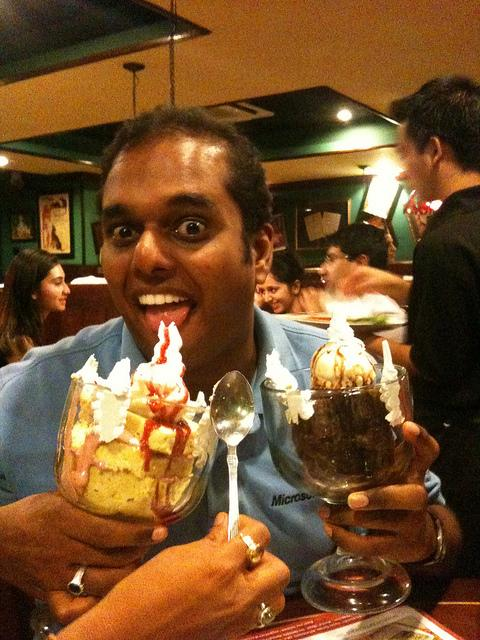What company might the man in the blue shirt work for? Please explain your reasoning. microsoft. As indicated by the logo and company name on the shirt. 